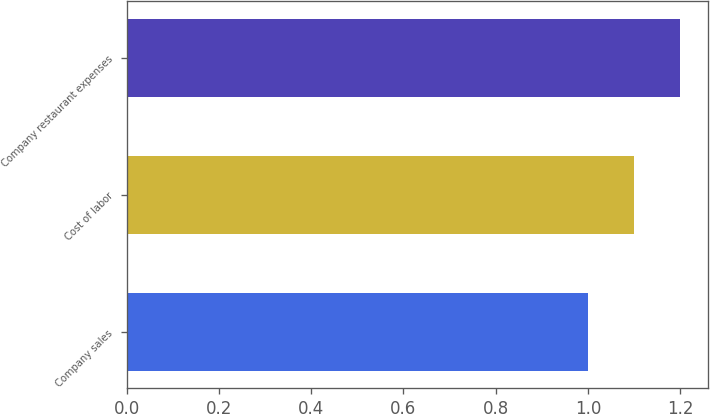Convert chart. <chart><loc_0><loc_0><loc_500><loc_500><bar_chart><fcel>Company sales<fcel>Cost of labor<fcel>Company restaurant expenses<nl><fcel>1<fcel>1.1<fcel>1.2<nl></chart> 